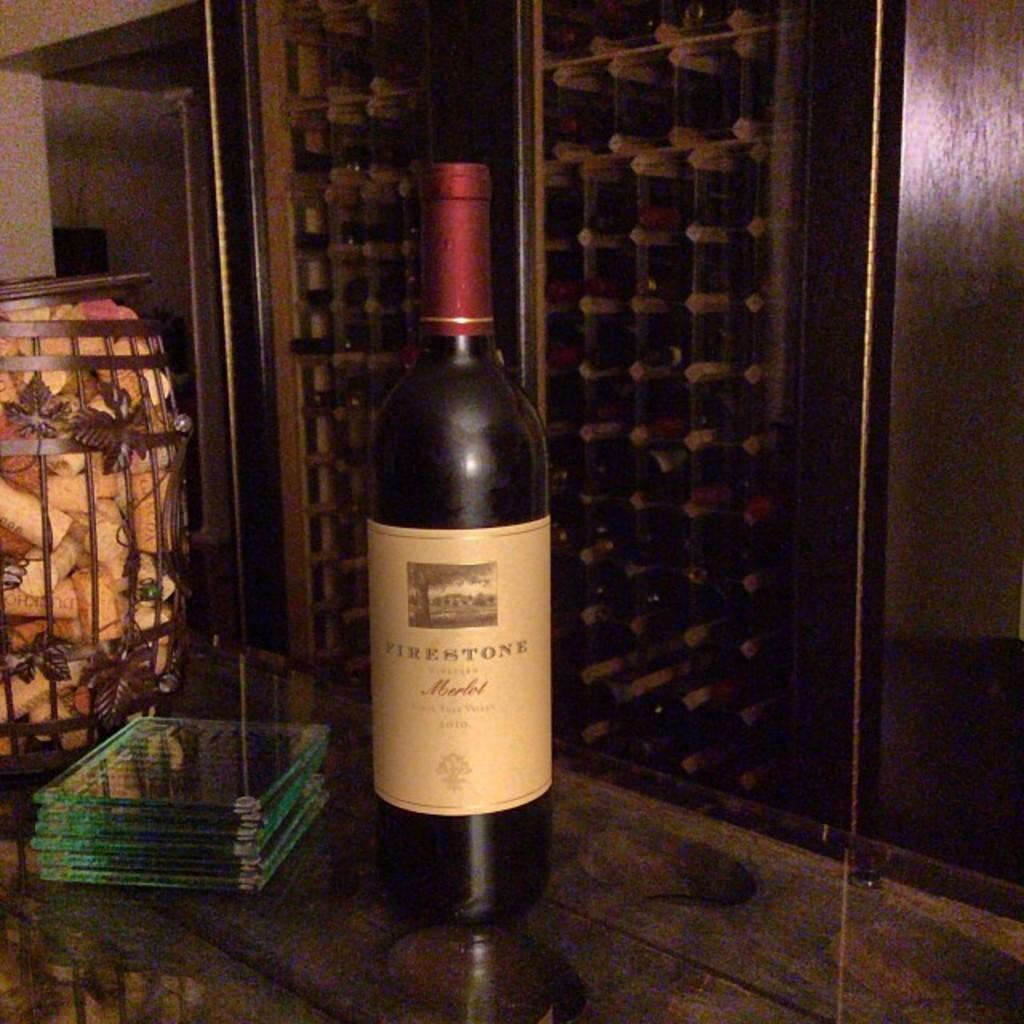<image>
Create a compact narrative representing the image presented. A bottle of Firestone wine showcased with coasters in a wine cellar in a restaurant. 